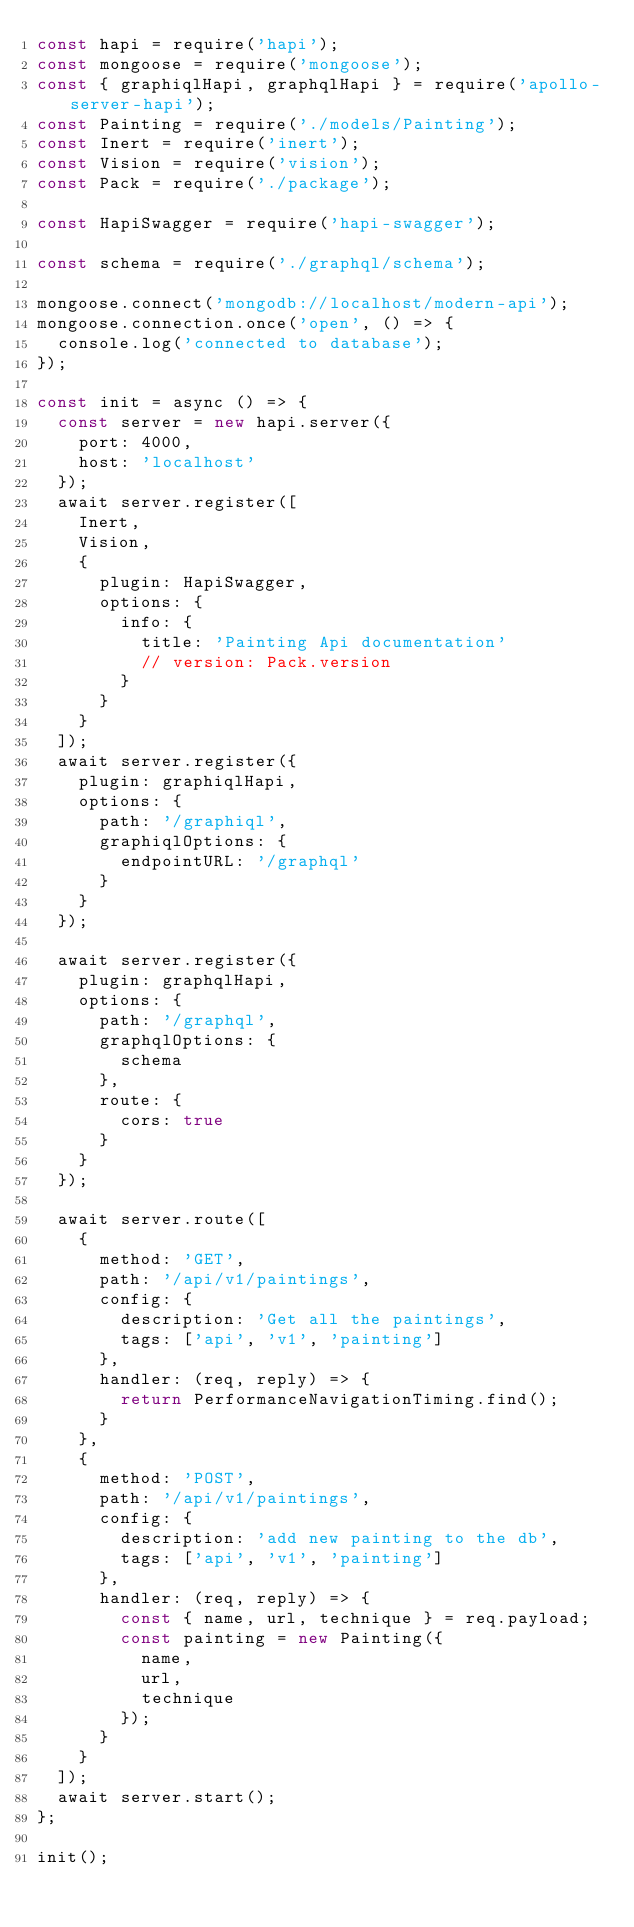<code> <loc_0><loc_0><loc_500><loc_500><_JavaScript_>const hapi = require('hapi');
const mongoose = require('mongoose');
const { graphiqlHapi, graphqlHapi } = require('apollo-server-hapi');
const Painting = require('./models/Painting');
const Inert = require('inert');
const Vision = require('vision');
const Pack = require('./package');

const HapiSwagger = require('hapi-swagger');

const schema = require('./graphql/schema');

mongoose.connect('mongodb://localhost/modern-api');
mongoose.connection.once('open', () => {
  console.log('connected to database');
});

const init = async () => {
  const server = new hapi.server({
    port: 4000,
    host: 'localhost'
  });
  await server.register([
    Inert,
    Vision,
    {
      plugin: HapiSwagger,
      options: {
        info: {
          title: 'Painting Api documentation'
          // version: Pack.version
        }
      }
    }
  ]);
  await server.register({
    plugin: graphiqlHapi,
    options: {
      path: '/graphiql',
      graphiqlOptions: {
        endpointURL: '/graphql'
      }
    }
  });

  await server.register({
    plugin: graphqlHapi,
    options: {
      path: '/graphql',
      graphqlOptions: {
        schema
      },
      route: {
        cors: true
      }
    }
  });

  await server.route([
    {
      method: 'GET',
      path: '/api/v1/paintings',
      config: {
        description: 'Get all the paintings',
        tags: ['api', 'v1', 'painting']
      },
      handler: (req, reply) => {
        return PerformanceNavigationTiming.find();
      }
    },
    {
      method: 'POST',
      path: '/api/v1/paintings',
      config: {
        description: 'add new painting to the db',
        tags: ['api', 'v1', 'painting']
      },
      handler: (req, reply) => {
        const { name, url, technique } = req.payload;
        const painting = new Painting({
          name,
          url,
          technique
        });
      }
    }
  ]);
  await server.start();
};

init();
</code> 